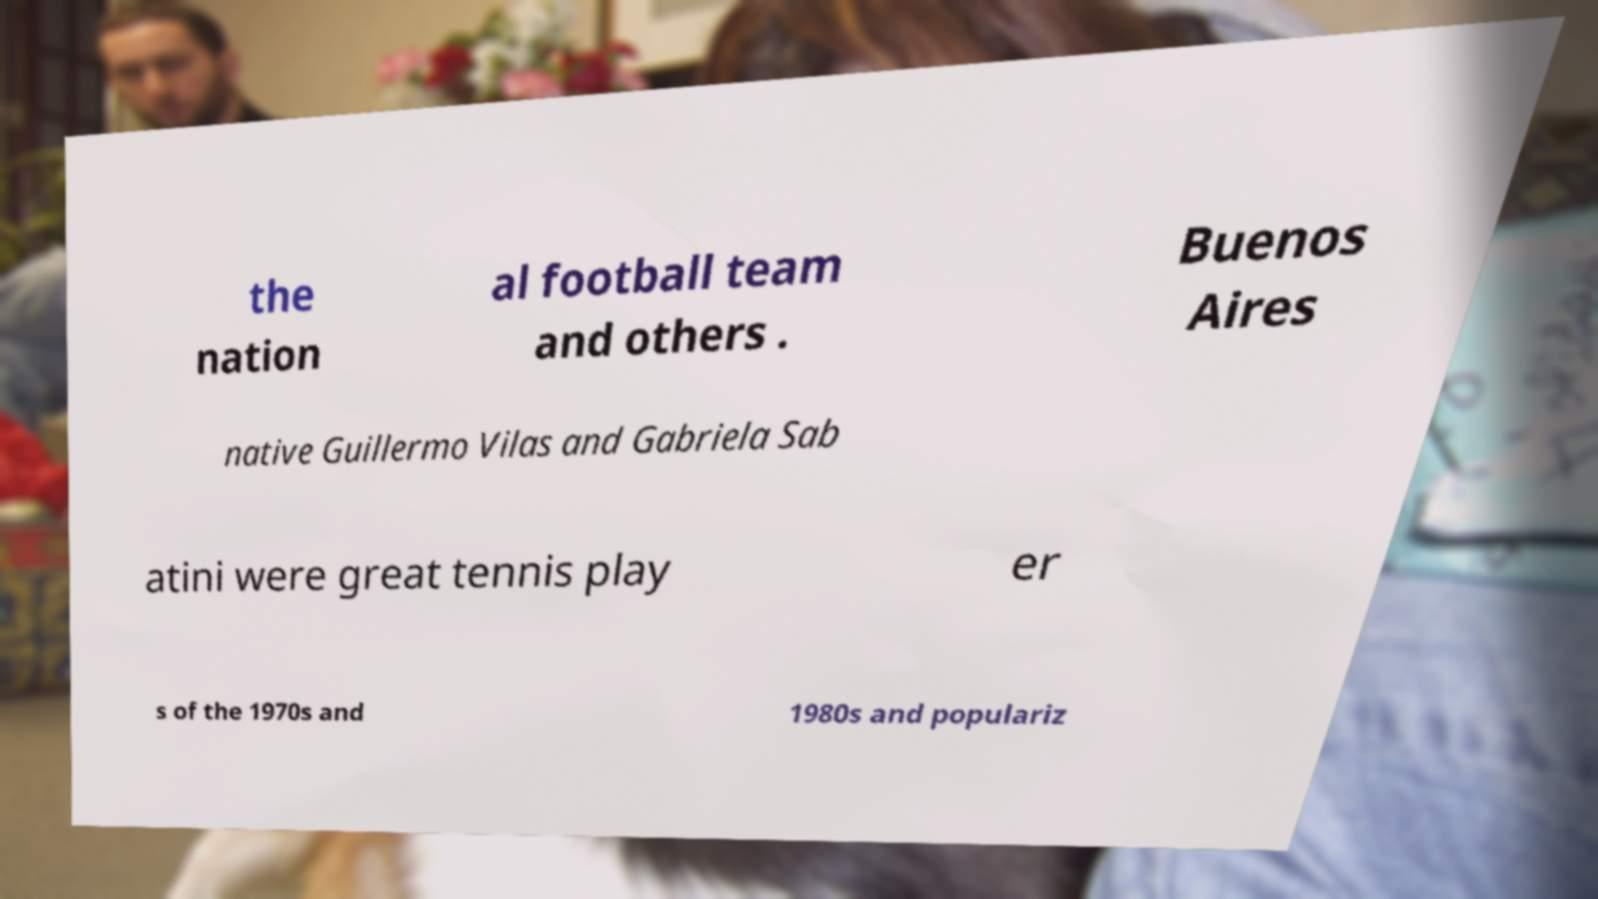I need the written content from this picture converted into text. Can you do that? the nation al football team and others . Buenos Aires native Guillermo Vilas and Gabriela Sab atini were great tennis play er s of the 1970s and 1980s and populariz 